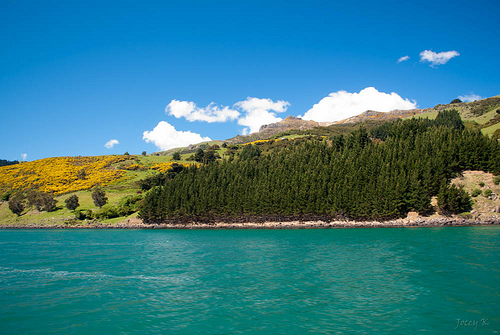<image>
Is there a water behind the grass? No. The water is not behind the grass. From this viewpoint, the water appears to be positioned elsewhere in the scene. 